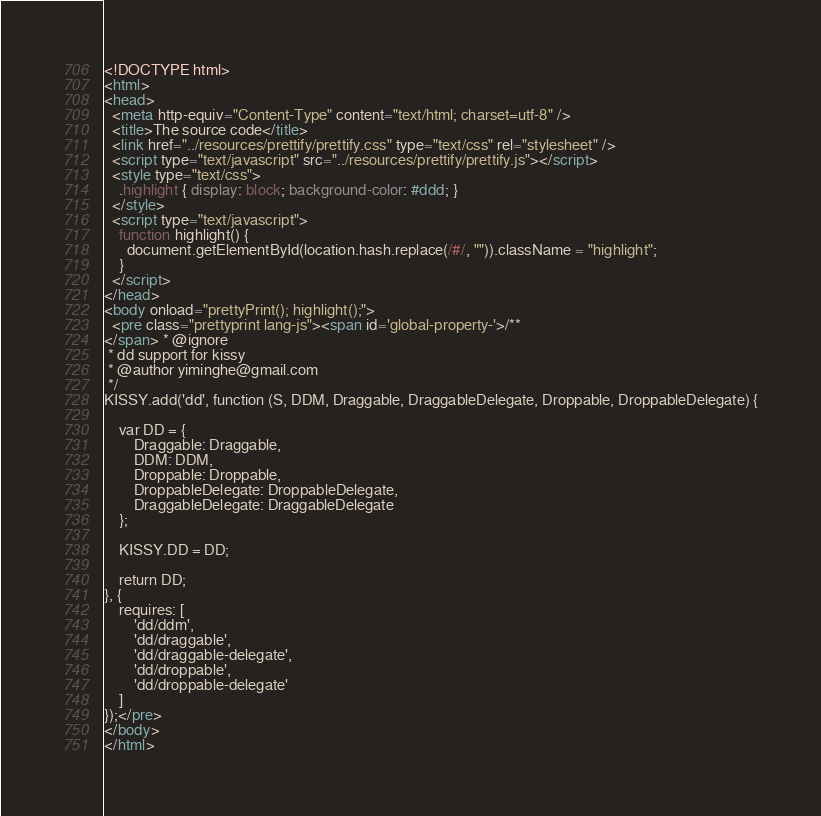<code> <loc_0><loc_0><loc_500><loc_500><_HTML_><!DOCTYPE html>
<html>
<head>
  <meta http-equiv="Content-Type" content="text/html; charset=utf-8" />
  <title>The source code</title>
  <link href="../resources/prettify/prettify.css" type="text/css" rel="stylesheet" />
  <script type="text/javascript" src="../resources/prettify/prettify.js"></script>
  <style type="text/css">
    .highlight { display: block; background-color: #ddd; }
  </style>
  <script type="text/javascript">
    function highlight() {
      document.getElementById(location.hash.replace(/#/, "")).className = "highlight";
    }
  </script>
</head>
<body onload="prettyPrint(); highlight();">
  <pre class="prettyprint lang-js"><span id='global-property-'>/**
</span> * @ignore
 * dd support for kissy
 * @author yiminghe@gmail.com
 */
KISSY.add('dd', function (S, DDM, Draggable, DraggableDelegate, Droppable, DroppableDelegate) {

    var DD = {
        Draggable: Draggable,
        DDM: DDM,
        Droppable: Droppable,
        DroppableDelegate: DroppableDelegate,
        DraggableDelegate: DraggableDelegate
    };

    KISSY.DD = DD;

    return DD;
}, {
    requires: [
        'dd/ddm',
        'dd/draggable',
        'dd/draggable-delegate',
        'dd/droppable',
        'dd/droppable-delegate'
    ]
});</pre>
</body>
</html>
</code> 